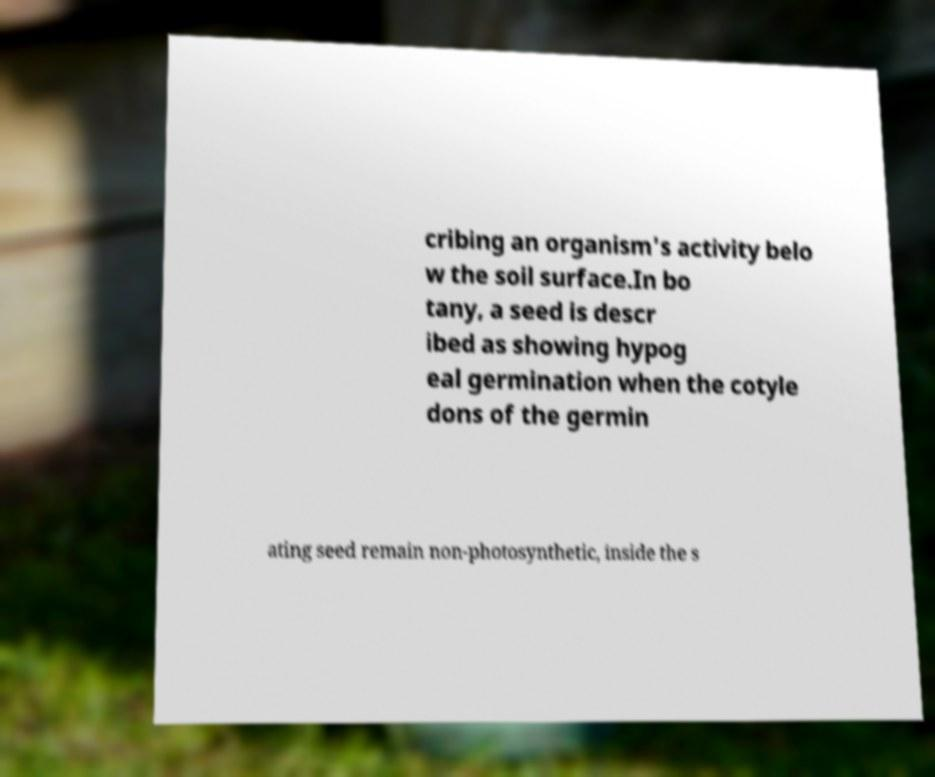Please read and relay the text visible in this image. What does it say? cribing an organism's activity belo w the soil surface.In bo tany, a seed is descr ibed as showing hypog eal germination when the cotyle dons of the germin ating seed remain non-photosynthetic, inside the s 